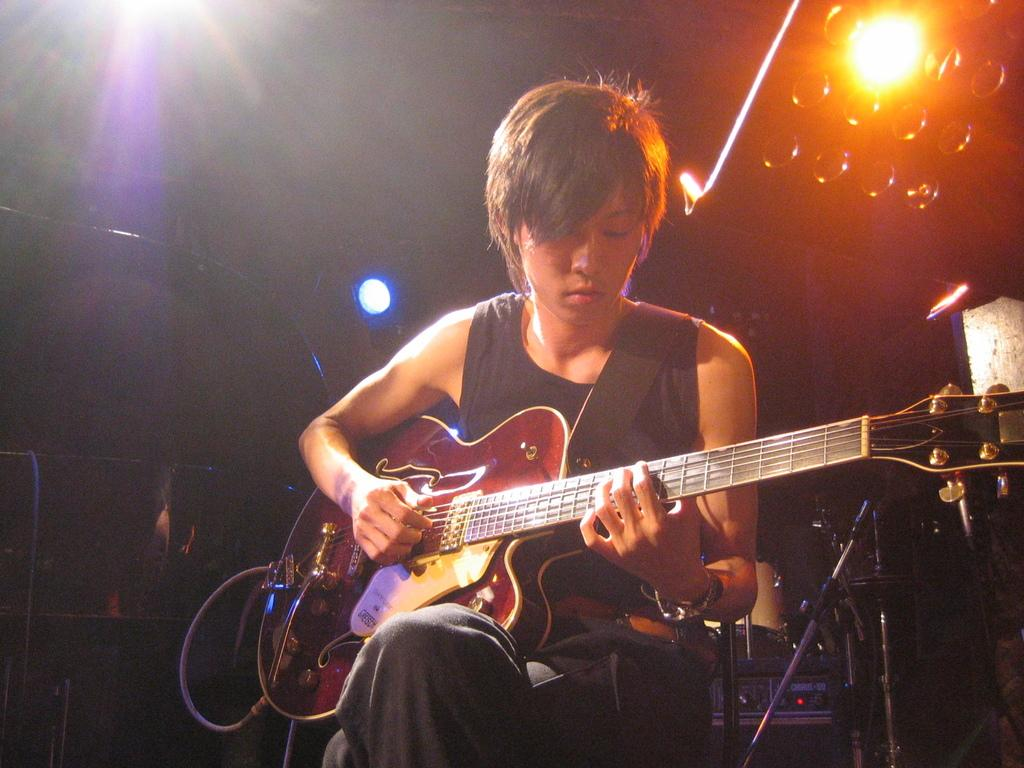What is the main subject of the image? There is a person in the image. What is the person holding in the image? The person is holding a guitar. Can you describe the background of the image? There is a light visible in the background of the image. What type of shoes is the person wearing in the image? There is no information about shoes in the image, as the focus is on the person holding a guitar. 